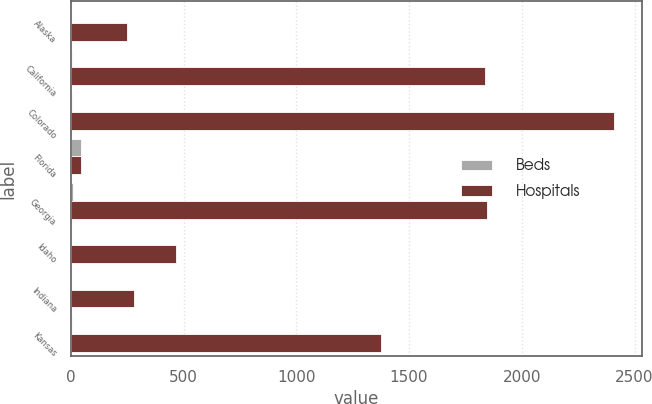Convert chart to OTSL. <chart><loc_0><loc_0><loc_500><loc_500><stacked_bar_chart><ecel><fcel>Alaska<fcel>California<fcel>Colorado<fcel>Florida<fcel>Georgia<fcel>Idaho<fcel>Indiana<fcel>Kansas<nl><fcel>Beds<fcel>1<fcel>5<fcel>7<fcel>45<fcel>8<fcel>2<fcel>1<fcel>4<nl><fcel>Hospitals<fcel>250<fcel>1838<fcel>2411<fcel>45<fcel>1847<fcel>468<fcel>278<fcel>1374<nl></chart> 